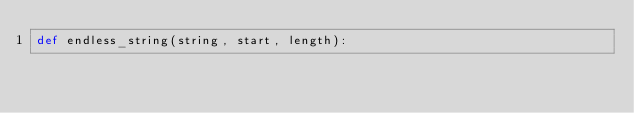<code> <loc_0><loc_0><loc_500><loc_500><_Python_>def endless_string(string, start, length):
	</code> 